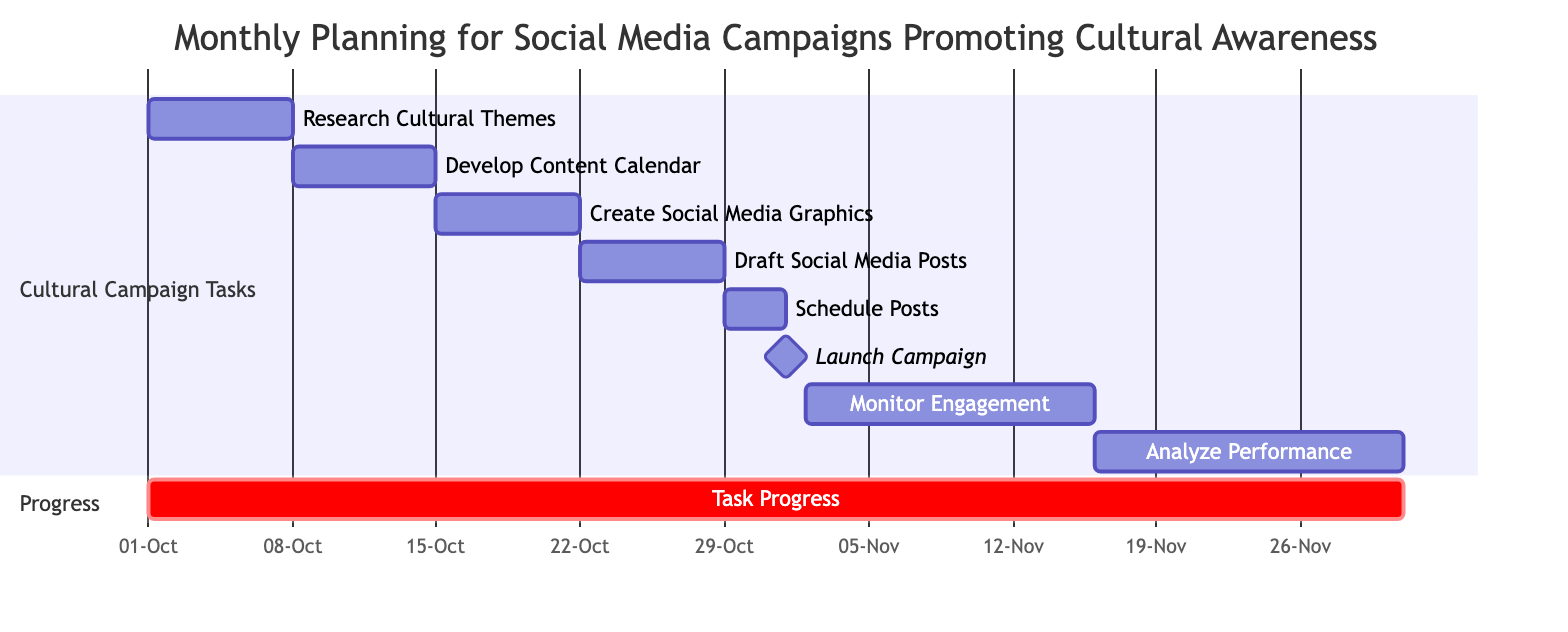What is the duration of the "Draft Social Media Posts" task? The task "Draft Social Media Posts" starts on October 22, 2023, and ends on October 28, 2023. This gives it a duration of 7 days.
Answer: 7 days How many tasks are scheduled before the "Launch Cultural Awareness Campaign"? The tasks scheduled before the "Launch Cultural Awareness Campaign" (which is on November 1, 2023) are "Research Cultural Themes for Campaign," "Develop Content Calendar," "Create Social Media Graphics," "Draft Social Media Posts," and "Schedule Posts." There are 5 such tasks.
Answer: 5 What is the start date of the "Analyze Campaign Performance" task? The "Analyze Campaign Performance" task begins on November 16, 2023, as indicated on the Gantt chart under the respective task.
Answer: November 16, 2023 How many days does the "Monitor Engagement & Gather Feedback" task last? The task "Monitor Engagement & Gather Feedback" starts on November 2, 2023, and ends on November 15, 2023. The duration, therefore, is 14 days (from November 2 to November 15 inclusive).
Answer: 14 days Which task follows "Create Social Media Graphics"? The task that follows "Create Social Media Graphics" is "Draft Social Media Posts," as it starts immediately after and is the next listed task in the Gantt chart.
Answer: Draft Social Media Posts What is the relationship between "Schedule Posts" and "Launch Cultural Awareness Campaign"? "Schedule Posts" must be completed before the "Launch Cultural Awareness Campaign" can take place, as the scheduling of posts typically happens just prior to the campaign launch.
Answer: Schedule Posts How long after the "Launch Cultural Awareness Campaign" does the "Analyze Campaign Performance" task start? The "Launch Cultural Awareness Campaign" occurs on November 1, 2023, and the "Analyze Campaign Performance" begins on November 16, 2023. There are 15 days between these two dates.
Answer: 15 days What is the latest end date among all tasks? The task with the latest end date is "Analyze Campaign Performance," which concludes on November 30, 2023, making it the task that runs the longest in the project timeline of the Gantt chart.
Answer: November 30, 2023 